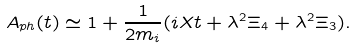<formula> <loc_0><loc_0><loc_500><loc_500>A _ { p h } ( t ) \simeq 1 + \frac { 1 } { 2 m _ { i } } ( i X t + \lambda ^ { 2 } \Xi _ { 4 } + \lambda ^ { 2 } \Xi _ { 3 } ) .</formula> 